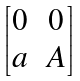Convert formula to latex. <formula><loc_0><loc_0><loc_500><loc_500>\begin{bmatrix} 0 & 0 \\ a & A \end{bmatrix}</formula> 